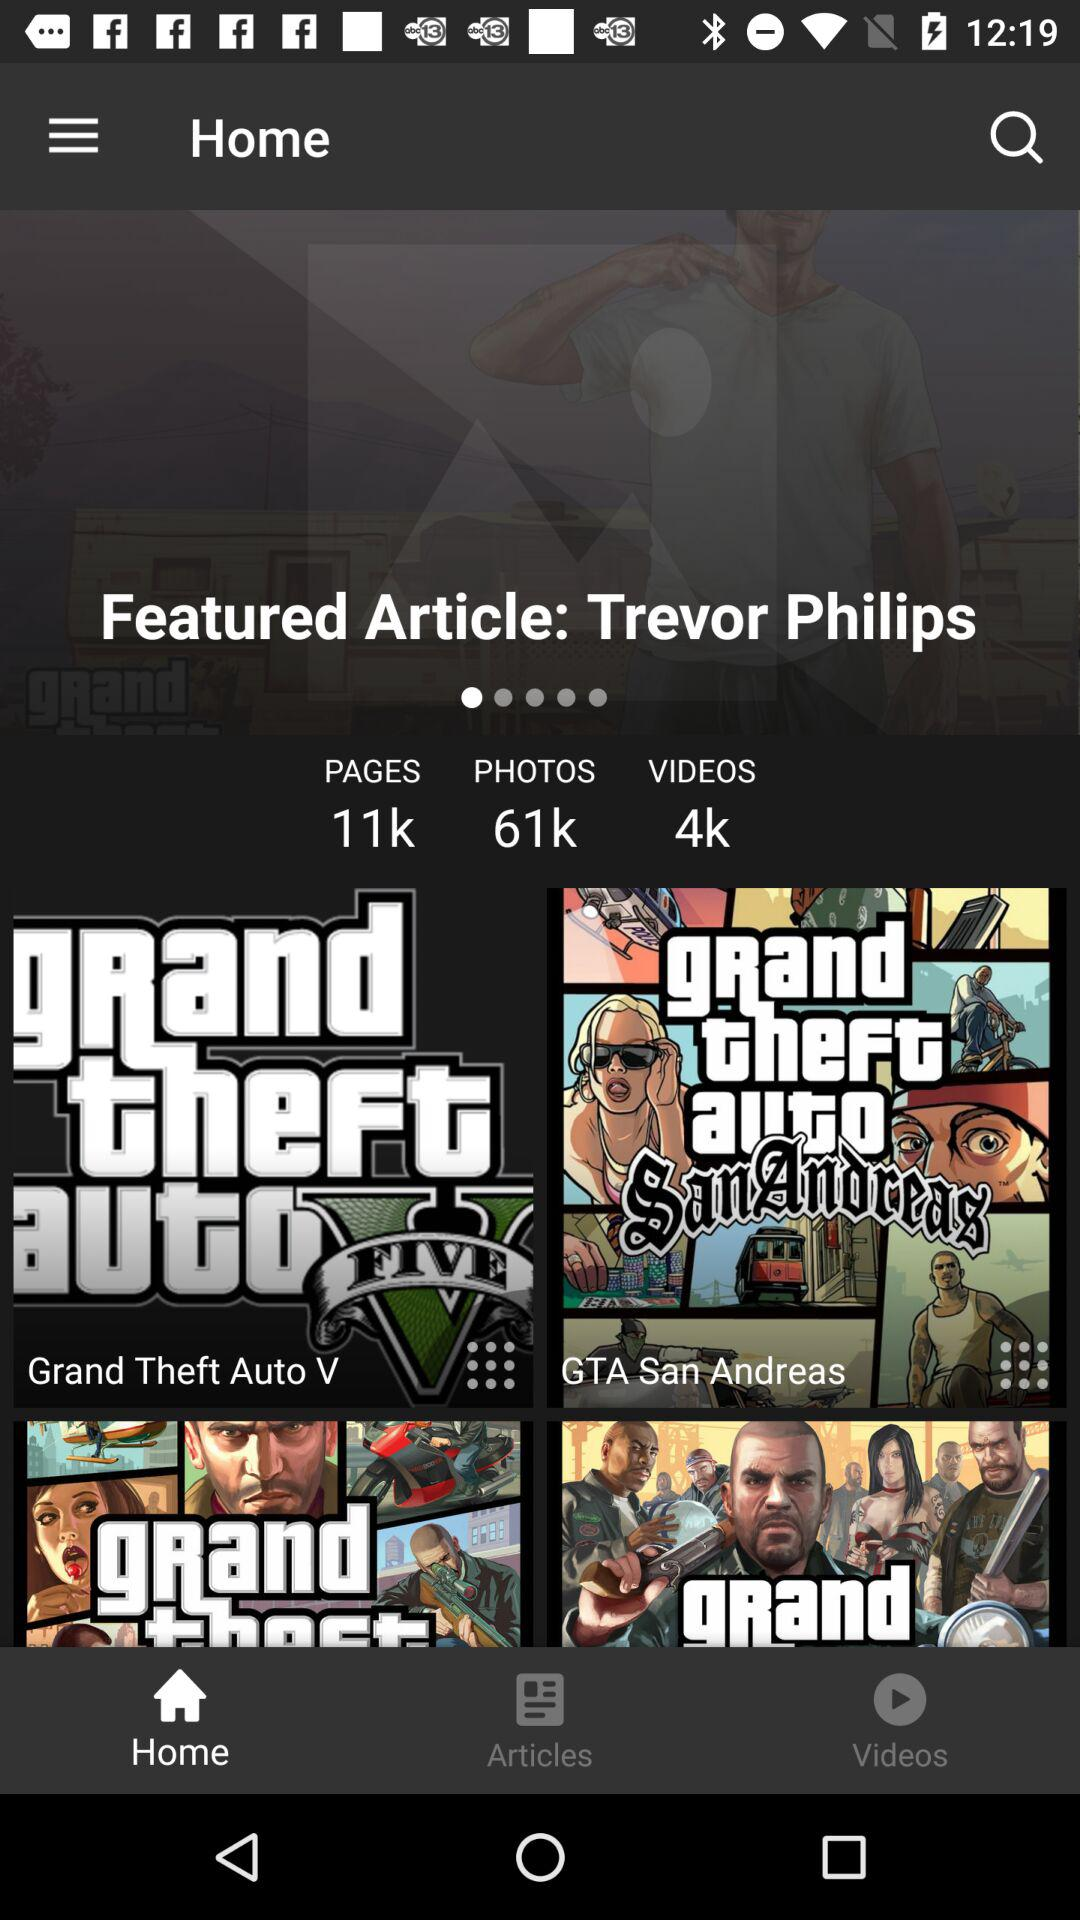What is the total count of videos? The total count of videos is 4k. 